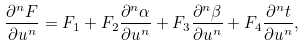<formula> <loc_0><loc_0><loc_500><loc_500>\frac { \partial ^ { n } F } { \partial u ^ { n } } = F _ { 1 } + F _ { 2 } \frac { \partial ^ { n } \alpha } { \partial u ^ { n } } + F _ { 3 } \frac { \partial ^ { n } \beta } { \partial u ^ { n } } + F _ { 4 } \frac { \partial ^ { n } t } { \partial u ^ { n } } ,</formula> 